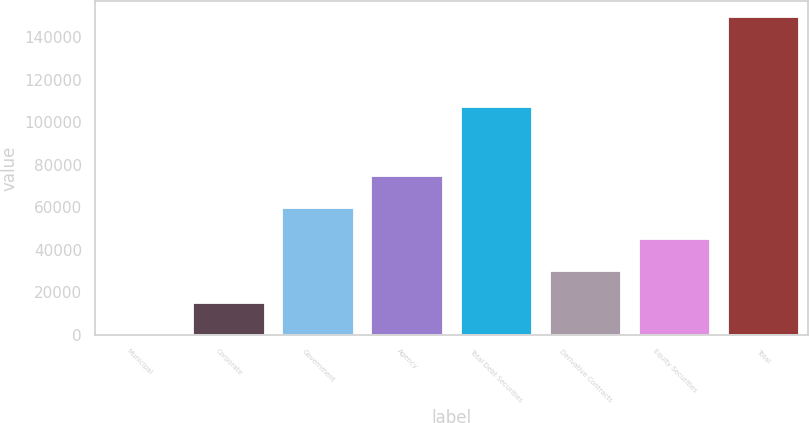Convert chart to OTSL. <chart><loc_0><loc_0><loc_500><loc_500><bar_chart><fcel>Municipal<fcel>Corporate<fcel>Government<fcel>Agency<fcel>Total Debt Securities<fcel>Derivative Contracts<fcel>Equity Securities<fcel>Total<nl><fcel>54<fcel>15021.5<fcel>59924<fcel>74891.5<fcel>107110<fcel>29989<fcel>44956.5<fcel>149729<nl></chart> 